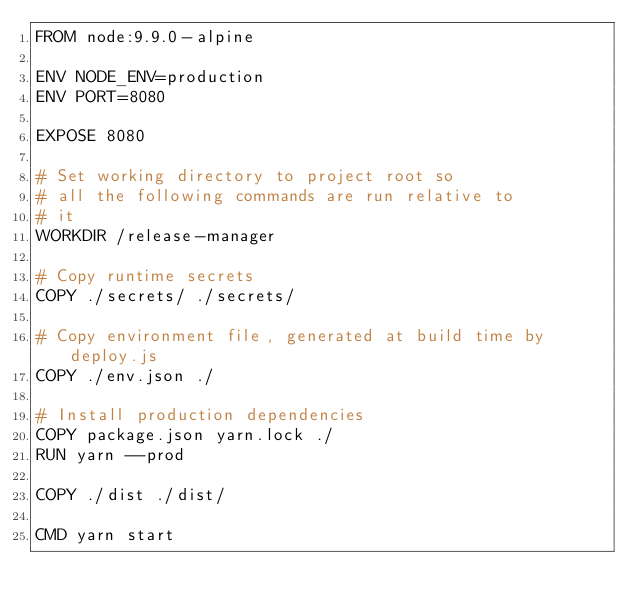Convert code to text. <code><loc_0><loc_0><loc_500><loc_500><_Dockerfile_>FROM node:9.9.0-alpine

ENV NODE_ENV=production
ENV PORT=8080

EXPOSE 8080

# Set working directory to project root so
# all the following commands are run relative to
# it
WORKDIR /release-manager

# Copy runtime secrets
COPY ./secrets/ ./secrets/

# Copy environment file, generated at build time by deploy.js
COPY ./env.json ./

# Install production dependencies
COPY package.json yarn.lock ./
RUN yarn --prod

COPY ./dist ./dist/

CMD yarn start
</code> 